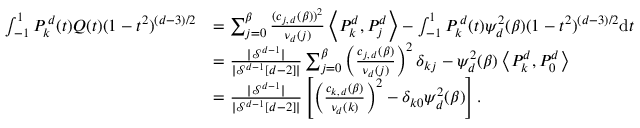Convert formula to latex. <formula><loc_0><loc_0><loc_500><loc_500>\begin{array} { r l } { \int _ { - 1 } ^ { 1 } P _ { k } ^ { \, d } ( t ) Q ( t ) ( 1 - t ^ { 2 } ) ^ { ( d - 3 ) / 2 } } & { = \sum _ { j = 0 } ^ { \beta } \frac { ( c _ { j , \, d } ( \beta ) ) ^ { 2 } } { \nu _ { d } ( j ) } \left \langle P _ { k } ^ { d } , P _ { j } ^ { d } \right \rangle - \int _ { - 1 } ^ { 1 } P _ { k } ^ { \, d } ( t ) \psi _ { d } ^ { 2 } ( \beta ) ( 1 - t ^ { 2 } ) ^ { ( d - 3 ) / 2 } d t } \\ & { = \frac { | \mathcal { S } ^ { d - 1 } | } { | \mathcal { S } ^ { d - 1 } [ d - 2 ] | } \sum _ { j = 0 } ^ { \beta } \left ( \frac { c _ { j , \, d } ( \beta ) } { \nu _ { d } ( j ) } \right ) ^ { 2 } \delta _ { k j } - \psi _ { d } ^ { 2 } ( \beta ) \left \langle P _ { k } ^ { d } , P _ { 0 } ^ { d } \right \rangle } \\ & { = \frac { | \mathcal { S } ^ { d - 1 } | } { | \mathcal { S } ^ { d - 1 } [ d - 2 ] | } \left [ \left ( \frac { c _ { k , \, d } ( \beta ) } { \nu _ { d } ( k ) } \right ) ^ { 2 } - \delta _ { k 0 } \psi _ { d } ^ { 2 } ( \beta ) \right ] . } \end{array}</formula> 